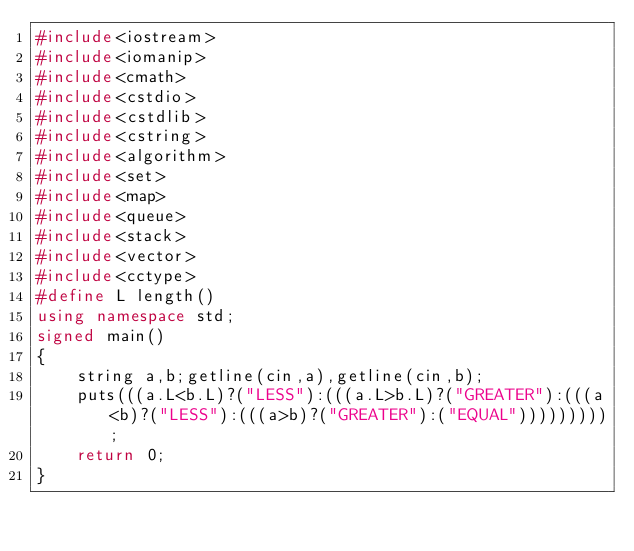<code> <loc_0><loc_0><loc_500><loc_500><_C++_>#include<iostream>
#include<iomanip>
#include<cmath>
#include<cstdio>
#include<cstdlib>
#include<cstring>
#include<algorithm>
#include<set>
#include<map>
#include<queue>
#include<stack>
#include<vector>
#include<cctype>
#define L length()
using namespace std;
signed main()
{
	string a,b;getline(cin,a),getline(cin,b);
	puts(((a.L<b.L)?("LESS"):(((a.L>b.L)?("GREATER"):(((a<b)?("LESS"):(((a>b)?("GREATER"):("EQUAL")))))))));
	return 0;
}</code> 